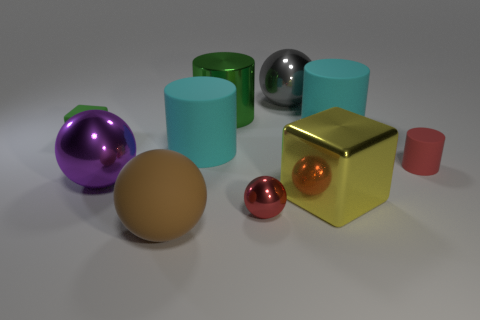Subtract all blue balls. Subtract all blue blocks. How many balls are left? 4 Subtract all balls. How many objects are left? 6 Subtract 1 green cylinders. How many objects are left? 9 Subtract all gray metal spheres. Subtract all small things. How many objects are left? 6 Add 2 big rubber things. How many big rubber things are left? 5 Add 3 metallic objects. How many metallic objects exist? 8 